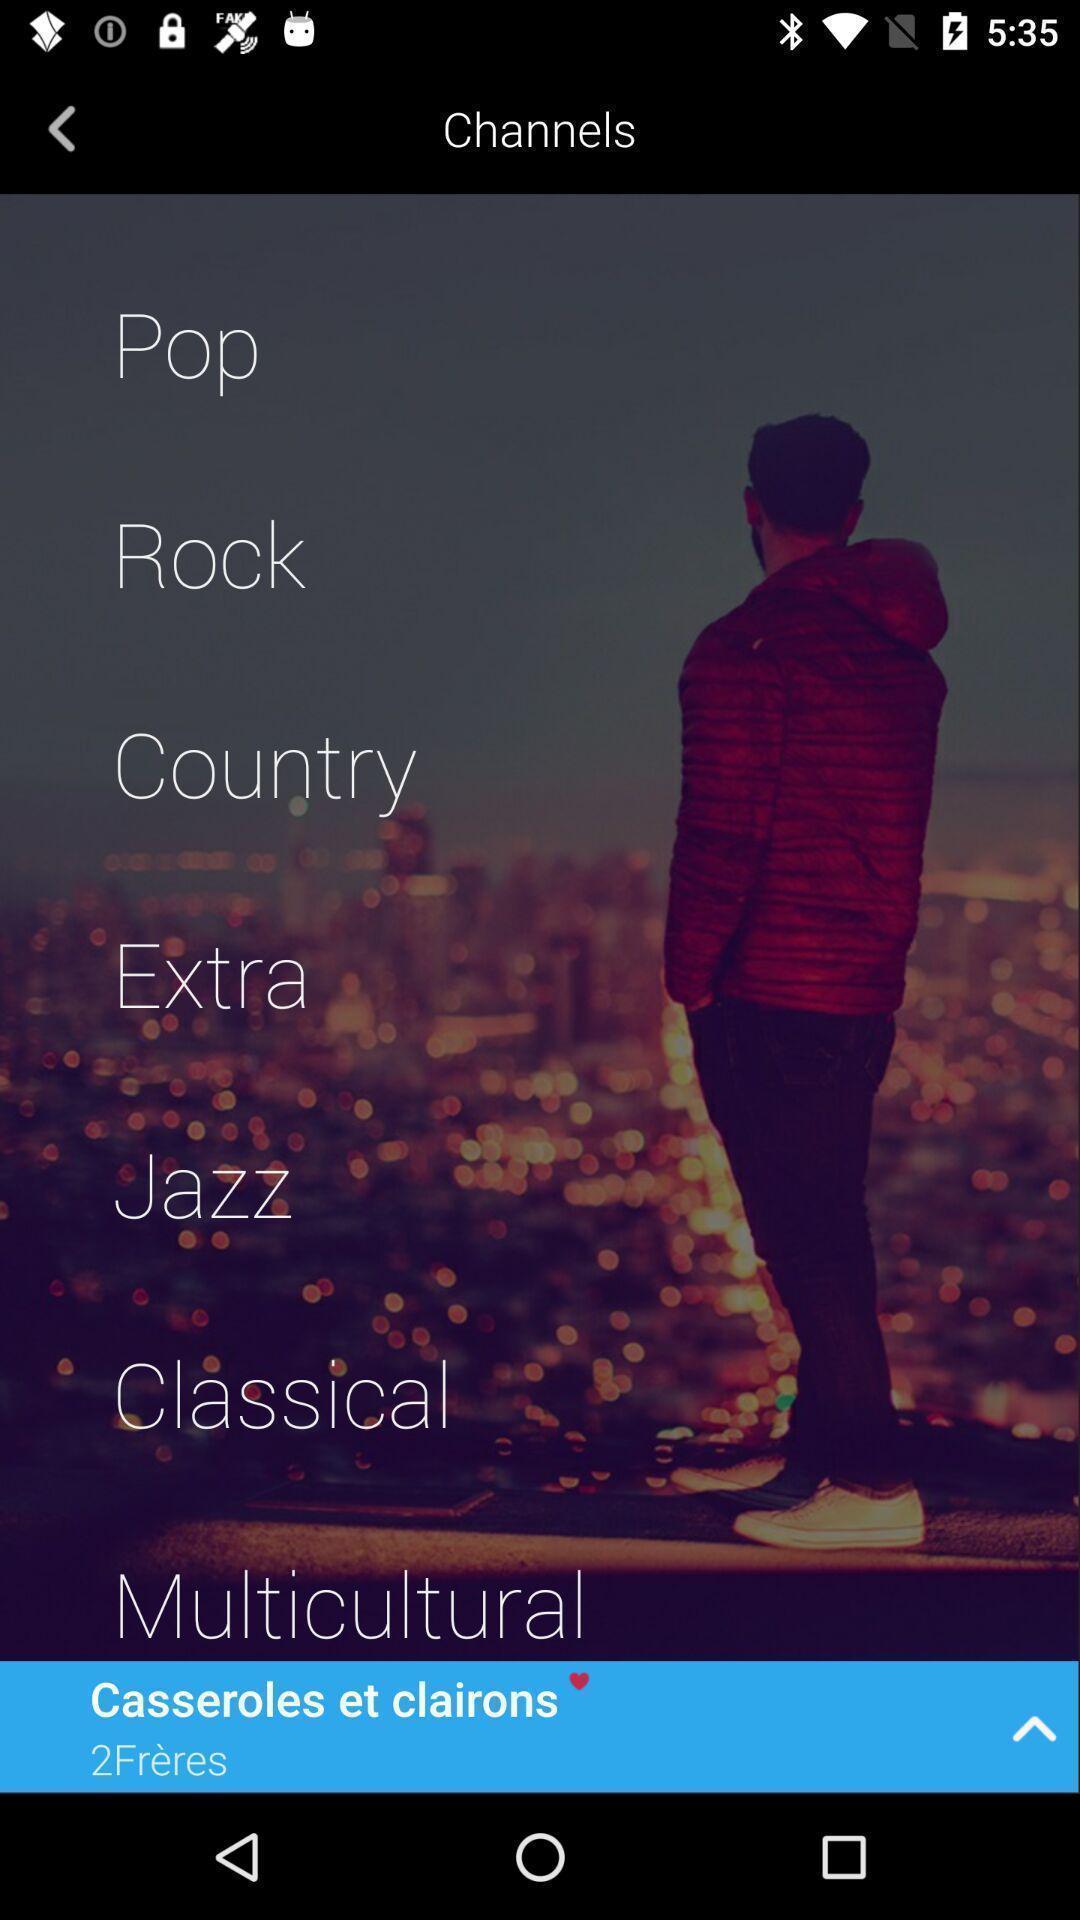Provide a description of this screenshot. Screen shows about a music community. 